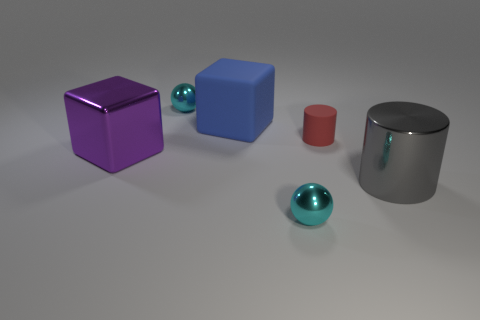Add 3 large matte blocks. How many objects exist? 9 Subtract all gray cylinders. How many cylinders are left? 1 Subtract 1 cubes. How many cubes are left? 1 Subtract 1 blue cubes. How many objects are left? 5 Subtract all blocks. How many objects are left? 4 Subtract all yellow spheres. Subtract all purple cylinders. How many spheres are left? 2 Subtract all tiny red rubber objects. Subtract all blocks. How many objects are left? 3 Add 2 red matte cylinders. How many red matte cylinders are left? 3 Add 1 purple blocks. How many purple blocks exist? 2 